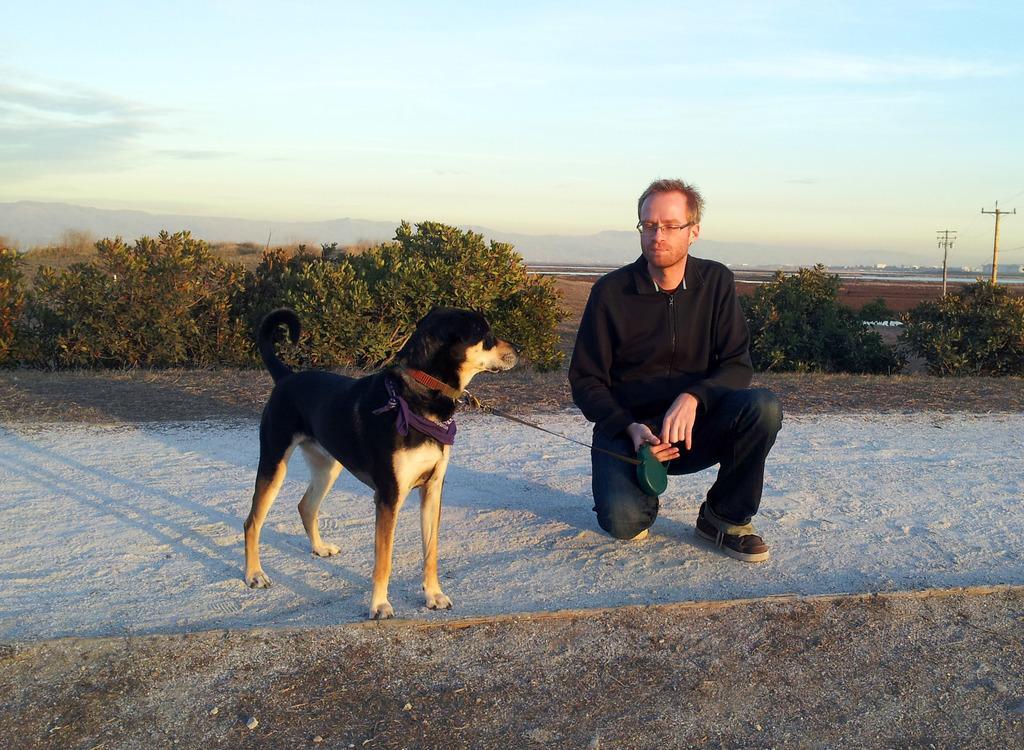Describe this image in one or two sentences. In the image we can see there is a man who is sitting and beside him there is a dog. 